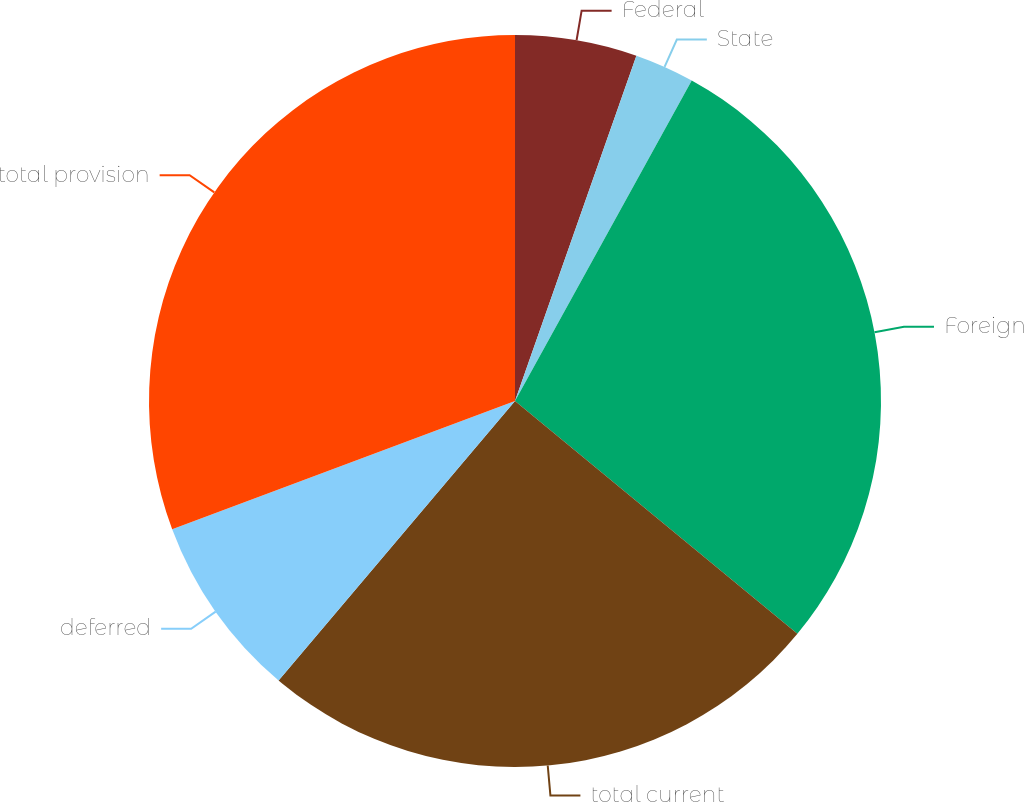<chart> <loc_0><loc_0><loc_500><loc_500><pie_chart><fcel>Federal<fcel>State<fcel>Foreign<fcel>total current<fcel>deferred<fcel>total provision<nl><fcel>5.38%<fcel>2.64%<fcel>27.95%<fcel>25.2%<fcel>8.13%<fcel>30.69%<nl></chart> 